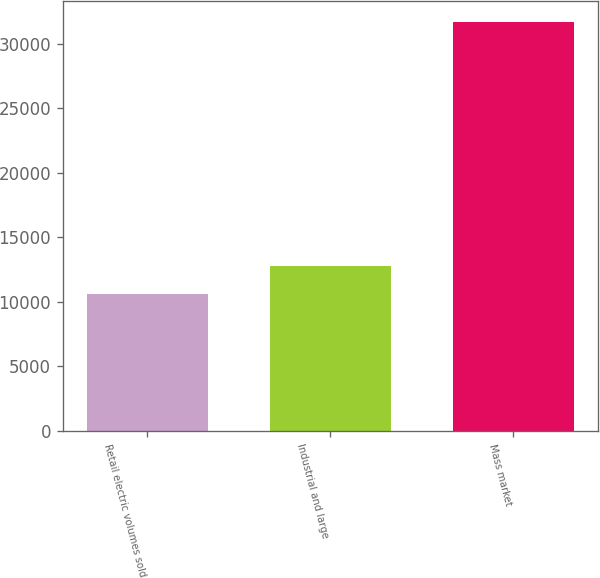<chart> <loc_0><loc_0><loc_500><loc_500><bar_chart><fcel>Retail electric volumes sold<fcel>Industrial and large<fcel>Mass market<nl><fcel>10633<fcel>12742.2<fcel>31725<nl></chart> 